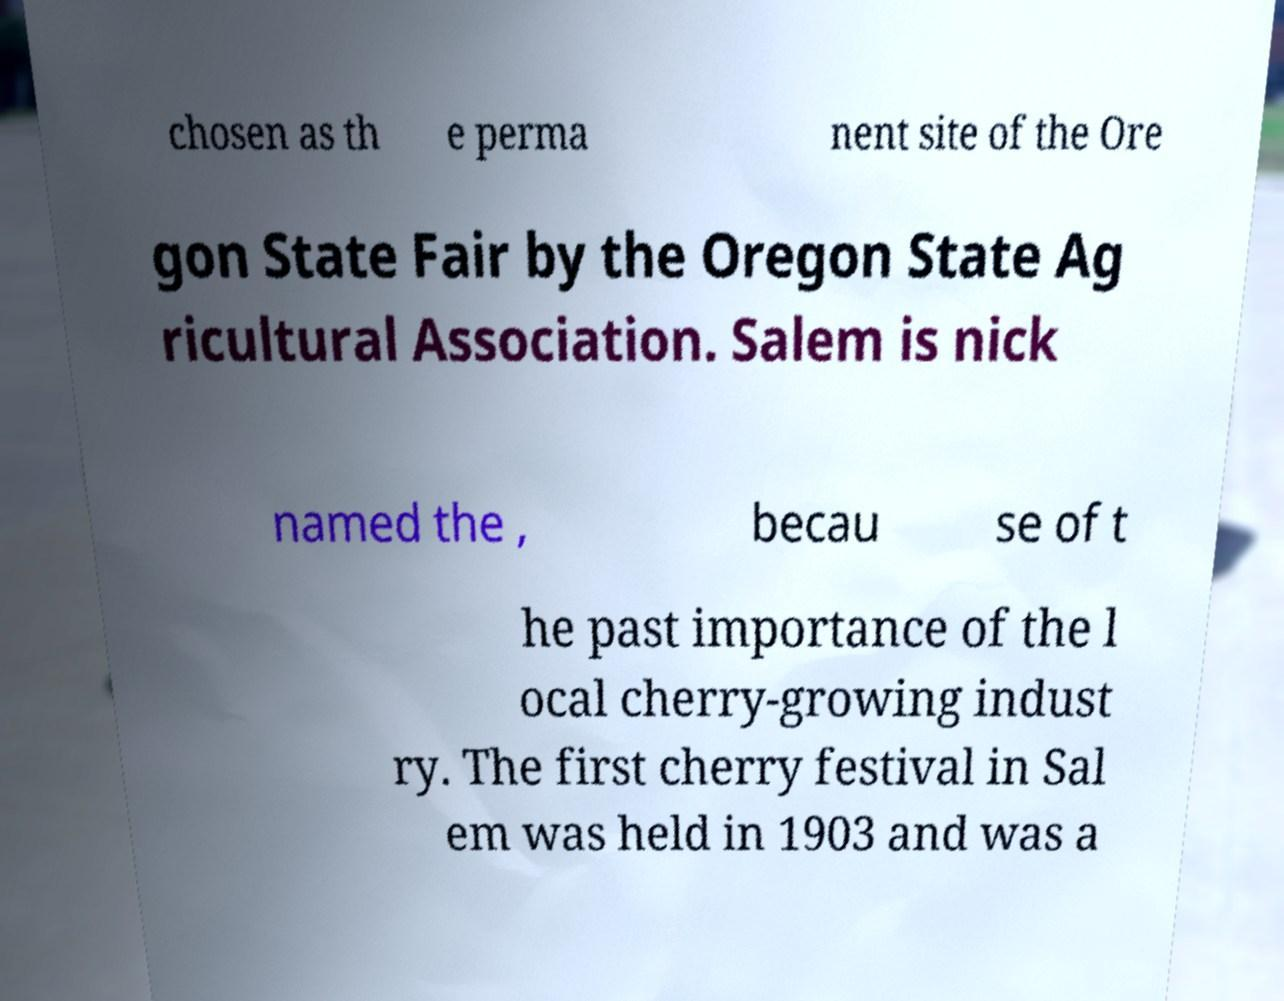Can you read and provide the text displayed in the image?This photo seems to have some interesting text. Can you extract and type it out for me? chosen as th e perma nent site of the Ore gon State Fair by the Oregon State Ag ricultural Association. Salem is nick named the , becau se of t he past importance of the l ocal cherry-growing indust ry. The first cherry festival in Sal em was held in 1903 and was a 